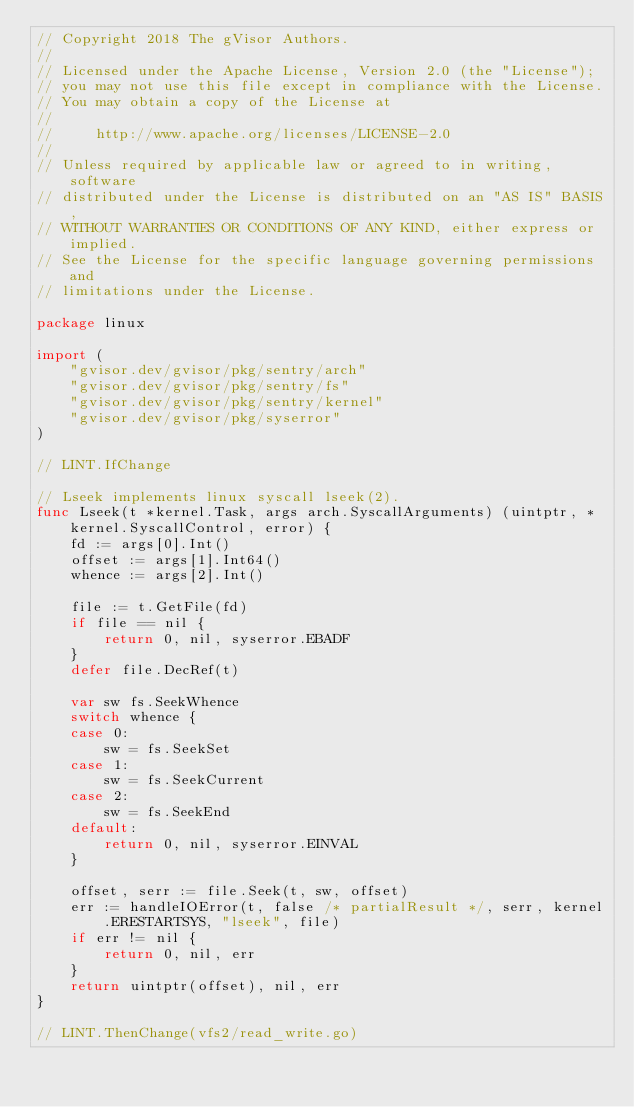Convert code to text. <code><loc_0><loc_0><loc_500><loc_500><_Go_>// Copyright 2018 The gVisor Authors.
//
// Licensed under the Apache License, Version 2.0 (the "License");
// you may not use this file except in compliance with the License.
// You may obtain a copy of the License at
//
//     http://www.apache.org/licenses/LICENSE-2.0
//
// Unless required by applicable law or agreed to in writing, software
// distributed under the License is distributed on an "AS IS" BASIS,
// WITHOUT WARRANTIES OR CONDITIONS OF ANY KIND, either express or implied.
// See the License for the specific language governing permissions and
// limitations under the License.

package linux

import (
	"gvisor.dev/gvisor/pkg/sentry/arch"
	"gvisor.dev/gvisor/pkg/sentry/fs"
	"gvisor.dev/gvisor/pkg/sentry/kernel"
	"gvisor.dev/gvisor/pkg/syserror"
)

// LINT.IfChange

// Lseek implements linux syscall lseek(2).
func Lseek(t *kernel.Task, args arch.SyscallArguments) (uintptr, *kernel.SyscallControl, error) {
	fd := args[0].Int()
	offset := args[1].Int64()
	whence := args[2].Int()

	file := t.GetFile(fd)
	if file == nil {
		return 0, nil, syserror.EBADF
	}
	defer file.DecRef(t)

	var sw fs.SeekWhence
	switch whence {
	case 0:
		sw = fs.SeekSet
	case 1:
		sw = fs.SeekCurrent
	case 2:
		sw = fs.SeekEnd
	default:
		return 0, nil, syserror.EINVAL
	}

	offset, serr := file.Seek(t, sw, offset)
	err := handleIOError(t, false /* partialResult */, serr, kernel.ERESTARTSYS, "lseek", file)
	if err != nil {
		return 0, nil, err
	}
	return uintptr(offset), nil, err
}

// LINT.ThenChange(vfs2/read_write.go)
</code> 